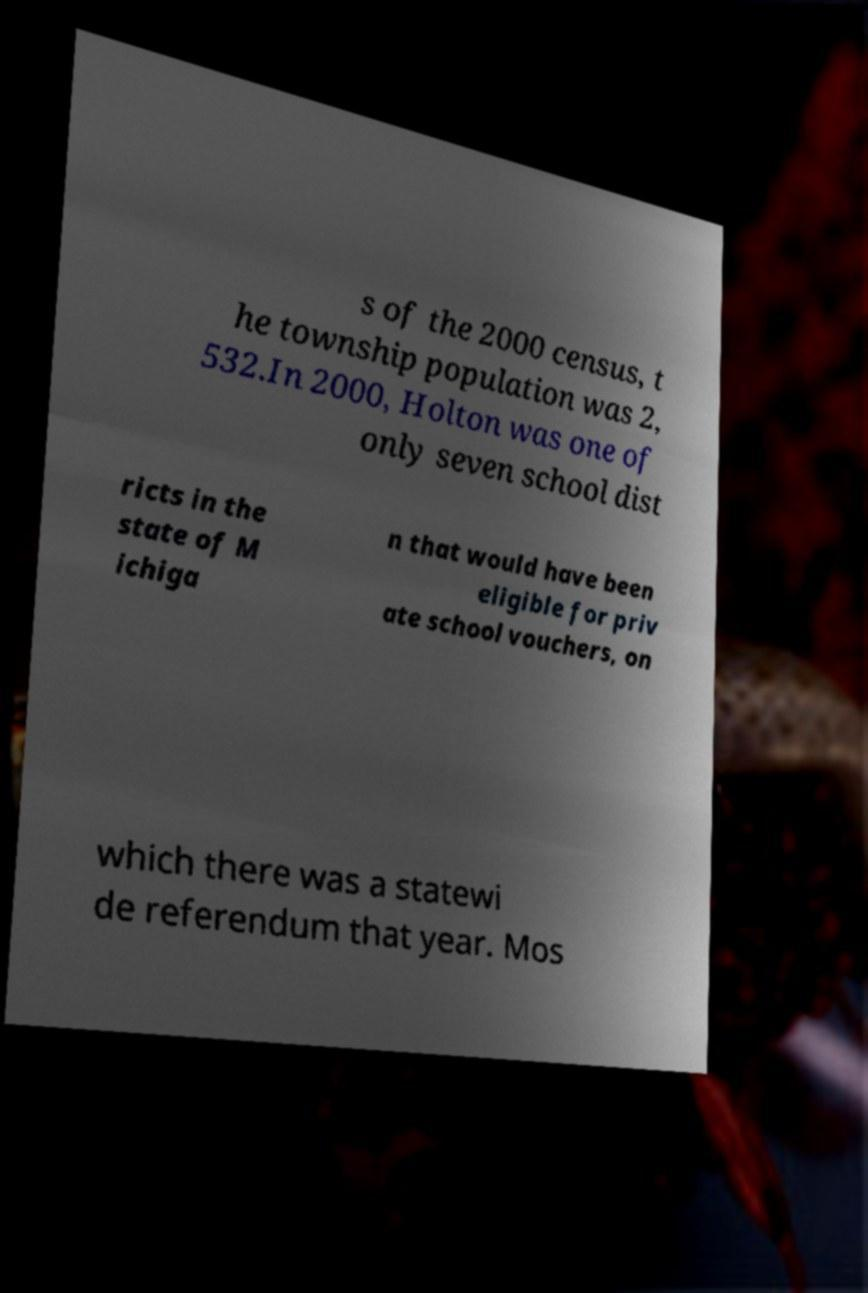Can you read and provide the text displayed in the image?This photo seems to have some interesting text. Can you extract and type it out for me? s of the 2000 census, t he township population was 2, 532.In 2000, Holton was one of only seven school dist ricts in the state of M ichiga n that would have been eligible for priv ate school vouchers, on which there was a statewi de referendum that year. Mos 